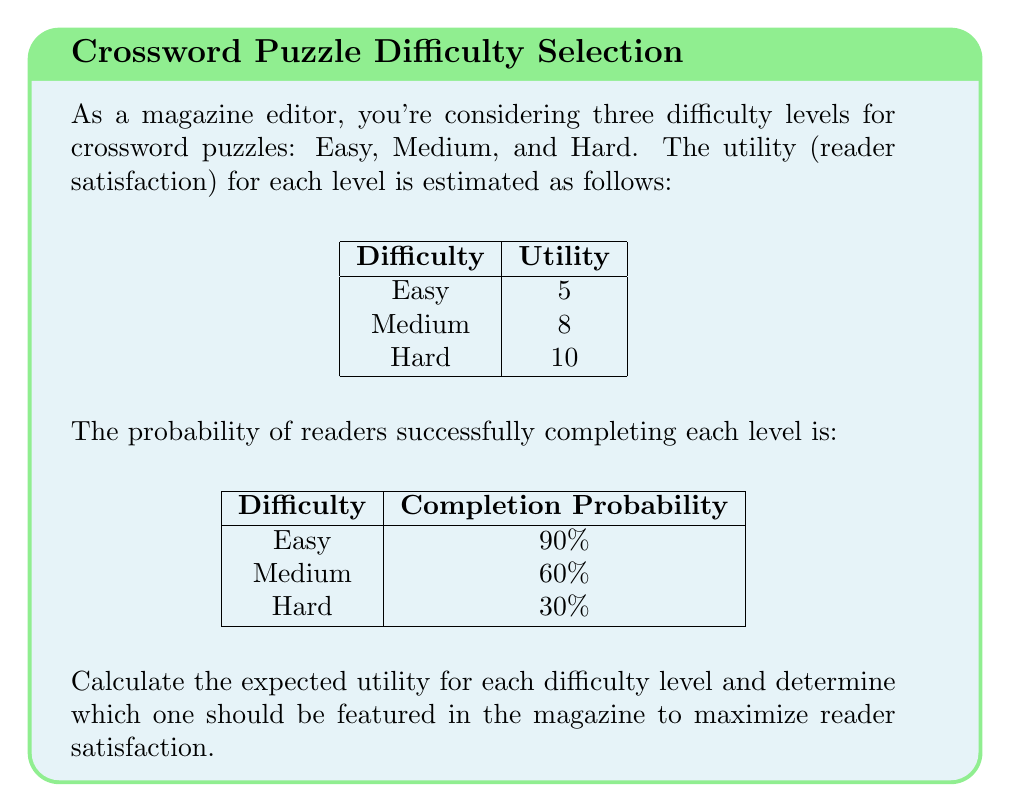Show me your answer to this math problem. To solve this problem, we'll calculate the expected utility for each difficulty level using the formula:

$$ E(U) = P(success) \times U(success) + P(failure) \times U(failure) $$

Where $E(U)$ is the expected utility, $P(success)$ is the probability of success, $U(success)$ is the utility of success, $P(failure)$ is the probability of failure, and $U(failure)$ is the utility of failure.

We'll assume that the utility of failure is 0 for all levels.

1. Easy level:
   $E(U_{easy}) = 0.90 \times 5 + 0.10 \times 0 = 4.5$

2. Medium level:
   $E(U_{medium}) = 0.60 \times 8 + 0.40 \times 0 = 4.8$

3. Hard level:
   $E(U_{hard}) = 0.30 \times 10 + 0.70 \times 0 = 3$

Comparing the expected utilities:
$E(U_{medium}) > E(U_{easy}) > E(U_{hard})$

Therefore, the Medium difficulty level has the highest expected utility and should be featured in the magazine to maximize reader satisfaction.
Answer: Medium difficulty (Expected Utility: 4.8) 